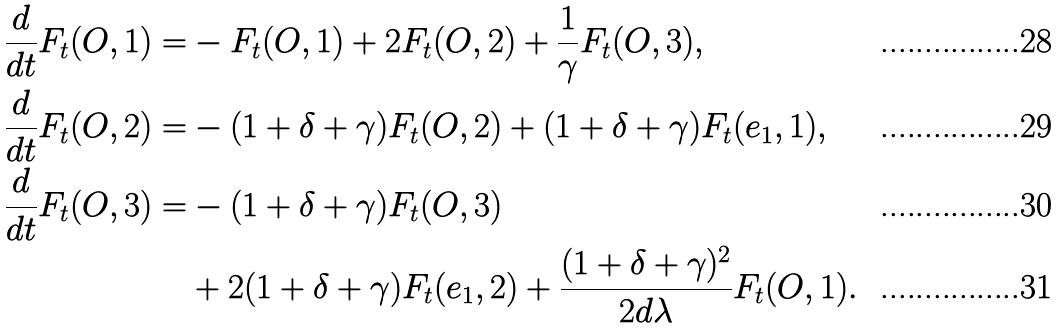Convert formula to latex. <formula><loc_0><loc_0><loc_500><loc_500>\frac { d } { d t } F _ { t } ( O , 1 ) = & - F _ { t } ( O , 1 ) + 2 F _ { t } ( O , 2 ) + \frac { 1 } { \gamma } F _ { t } ( O , 3 ) , \\ \frac { d } { d t } F _ { t } ( O , 2 ) = & - ( 1 + \delta + \gamma ) F _ { t } ( O , 2 ) + ( 1 + \delta + \gamma ) F _ { t } ( e _ { 1 } , 1 ) , \\ \frac { d } { d t } F _ { t } ( O , 3 ) = & - ( 1 + \delta + \gamma ) F _ { t } ( O , 3 ) \\ & + 2 ( 1 + \delta + \gamma ) F _ { t } ( e _ { 1 } , 2 ) + \frac { ( 1 + \delta + \gamma ) ^ { 2 } } { 2 d \lambda } F _ { t } ( O , 1 ) .</formula> 